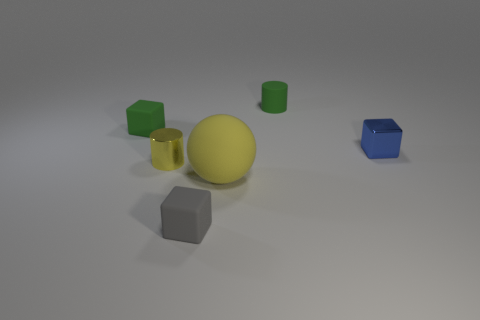Is there anything else that has the same size as the sphere?
Your answer should be very brief. No. What size is the yellow matte thing?
Give a very brief answer. Large. What color is the large object that is made of the same material as the small green block?
Keep it short and to the point. Yellow. Is the shape of the green rubber object to the left of the yellow shiny thing the same as the small green thing that is right of the small yellow object?
Offer a terse response. No. What number of rubber things are yellow spheres or tiny blocks?
Ensure brevity in your answer.  3. There is a thing that is the same color as the small rubber cylinder; what is it made of?
Your answer should be compact. Rubber. Are there any other things that have the same shape as the tiny blue metal object?
Give a very brief answer. Yes. What is the small cube in front of the tiny yellow metal cylinder made of?
Ensure brevity in your answer.  Rubber. Are the small yellow cylinder that is behind the big object and the blue cube made of the same material?
Give a very brief answer. Yes. What number of things are tiny rubber cubes or rubber blocks to the right of the green rubber block?
Provide a short and direct response. 2. 